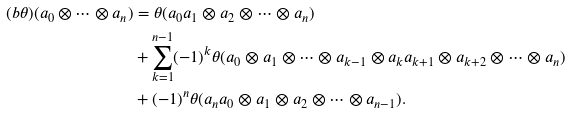<formula> <loc_0><loc_0><loc_500><loc_500>( b \theta ) ( a _ { 0 } \otimes \cdots \otimes a _ { n } ) & = \theta ( a _ { 0 } a _ { 1 } \otimes a _ { 2 } \otimes \cdots \otimes a _ { n } ) \\ & + \sum _ { k = 1 } ^ { n - 1 } ( - 1 ) ^ { k } \theta ( a _ { 0 } \otimes a _ { 1 } \otimes \cdots \otimes a _ { k - 1 } \otimes a _ { k } a _ { k + 1 } \otimes a _ { k + 2 } \otimes \cdots \otimes a _ { n } ) \\ & + ( - 1 ) ^ { n } \theta ( a _ { n } a _ { 0 } \otimes a _ { 1 } \otimes a _ { 2 } \otimes \cdots \otimes a _ { n - 1 } ) .</formula> 